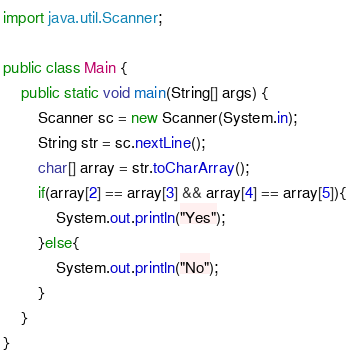<code> <loc_0><loc_0><loc_500><loc_500><_Java_>import java.util.Scanner;

public class Main {
    public static void main(String[] args) {
        Scanner sc = new Scanner(System.in);
        String str = sc.nextLine();
        char[] array = str.toCharArray();
        if(array[2] == array[3] && array[4] == array[5]){
            System.out.println("Yes");
        }else{
            System.out.println("No");
        }
    }
}</code> 